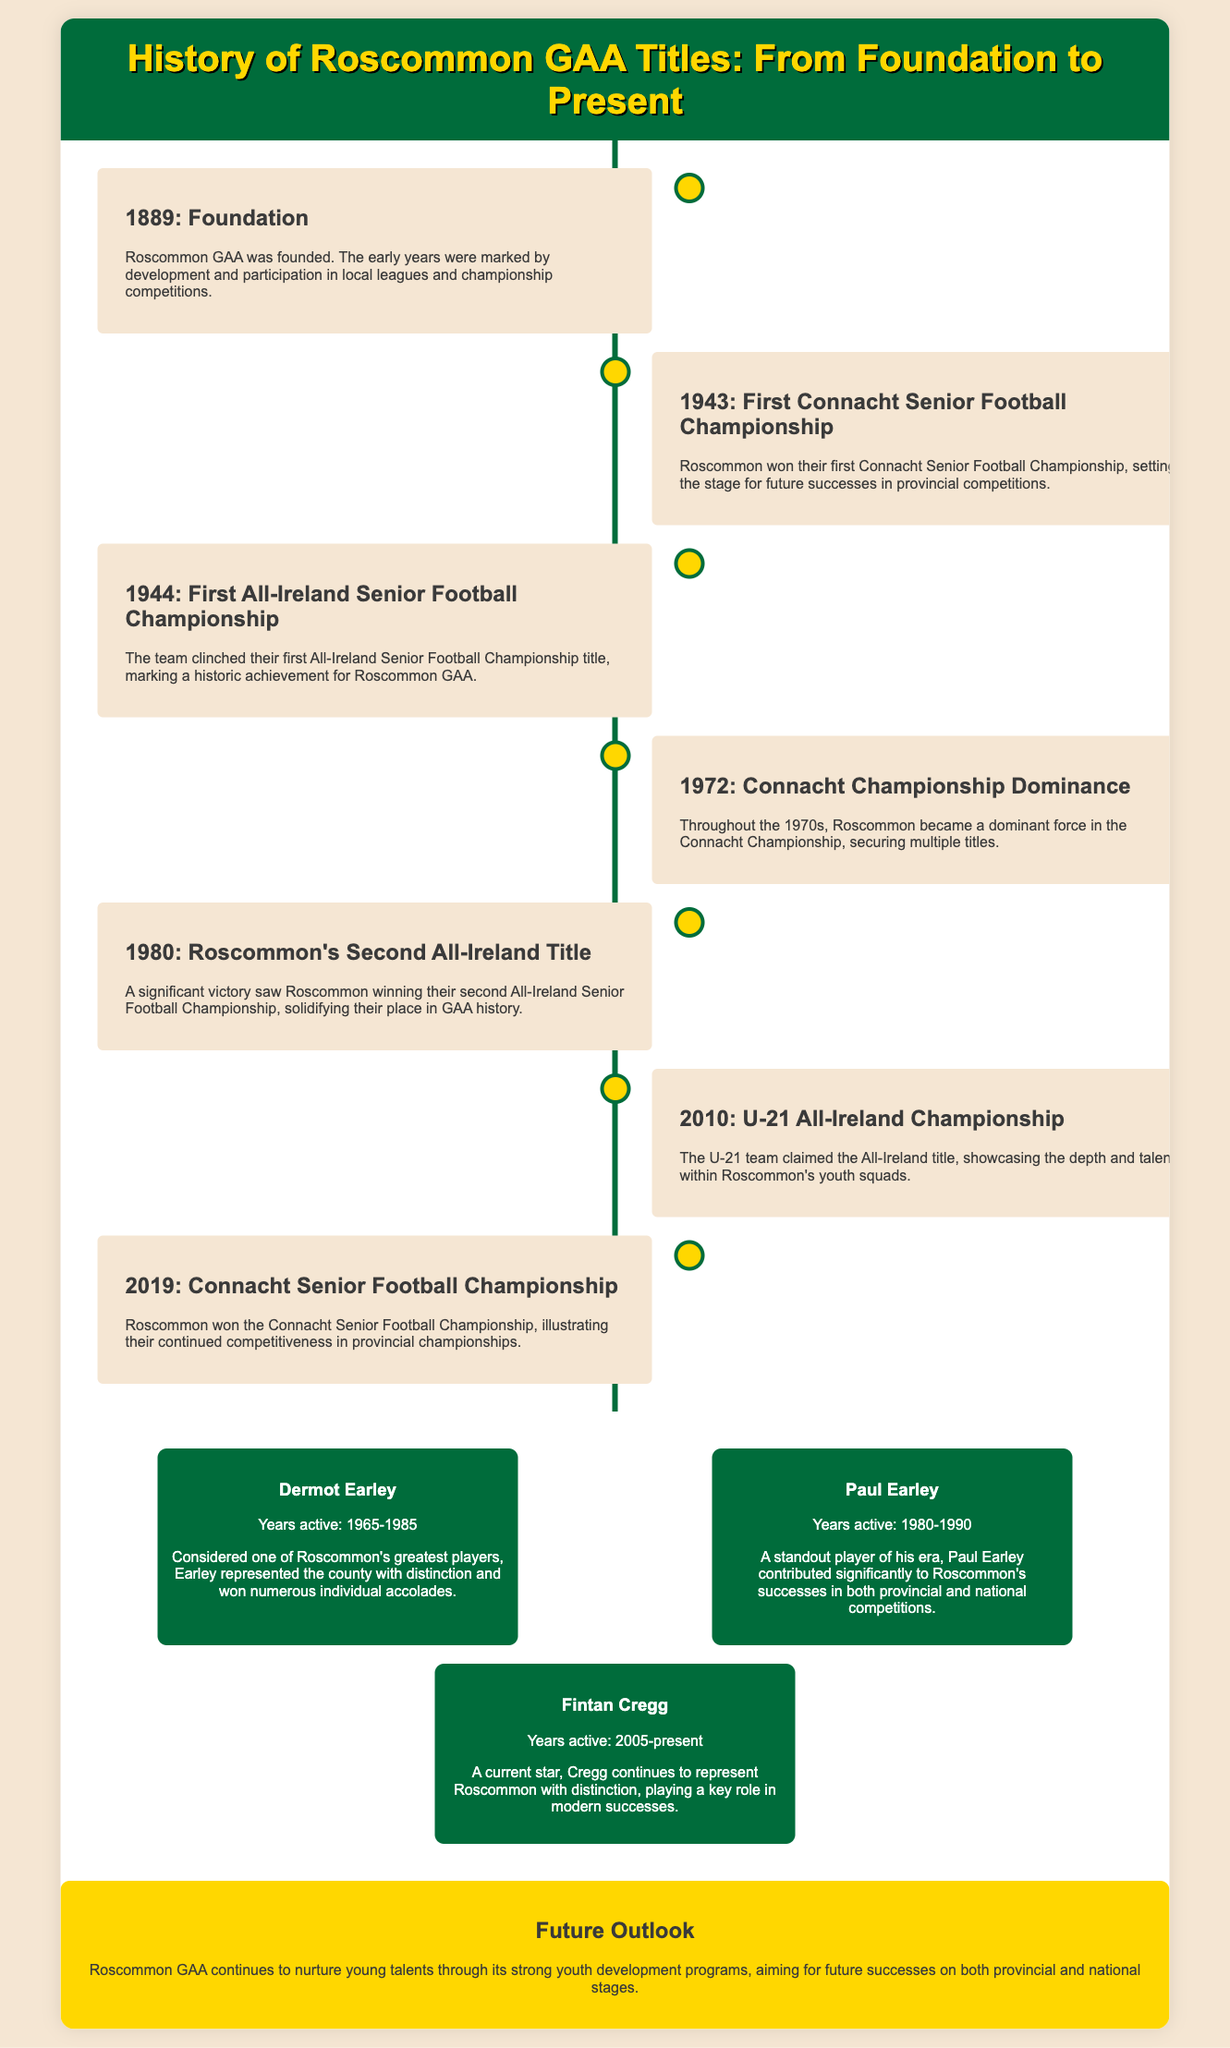What year was Roscommon GAA founded? The document states that Roscommon GAA was founded in 1889.
Answer: 1889 What notable achievement did Roscommon accomplish in 1944? According to the document, Roscommon clinched their first All-Ireland Senior Football Championship title in 1944.
Answer: First All-Ireland title Which year marks Roscommon's dominance in the Connacht Championship? The document indicates that Roscommon became a dominant force in the Connacht Championship during the 1970s, specifically noted in 1972.
Answer: 1972 How many All-Ireland Senior Football Championships has Roscommon won as of the document's last update? The document notes that Roscommon has won the All-Ireland title twice, with the first in 1944 and the second in 1980.
Answer: Two What is the name of a player who was active from 1965 to 1985? The document lists Dermot Earley as a player who was active during those years.
Answer: Dermot Earley What significant event for Roscommon took place in 2019? The document mentions that in 2019, Roscommon won the Connacht Senior Football Championship.
Answer: Connacht Senior Football Championship What does the future outlook suggest about Roscommon GAA? The future outlook indicates that Roscommon GAA is nurturing young talents through strong youth development programs.
Answer: Youth development programs Which title did Roscommon win for the first time in 1943? The document states that in 1943, Roscommon won their first Connacht Senior Football Championship.
Answer: Connacht Senior Football Championship Who is a current player mentioned in the document? The document highlights Fintan Cregg as a current player representing Roscommon.
Answer: Fintan Cregg 